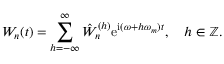Convert formula to latex. <formula><loc_0><loc_0><loc_500><loc_500>W _ { n } ( t ) = \sum _ { h = - \infty } ^ { \infty } \hat { W } _ { n } ^ { ( h ) } e ^ { i ( \omega + h \omega _ { m } ) t } , \quad h \in \mathbb { Z } .</formula> 